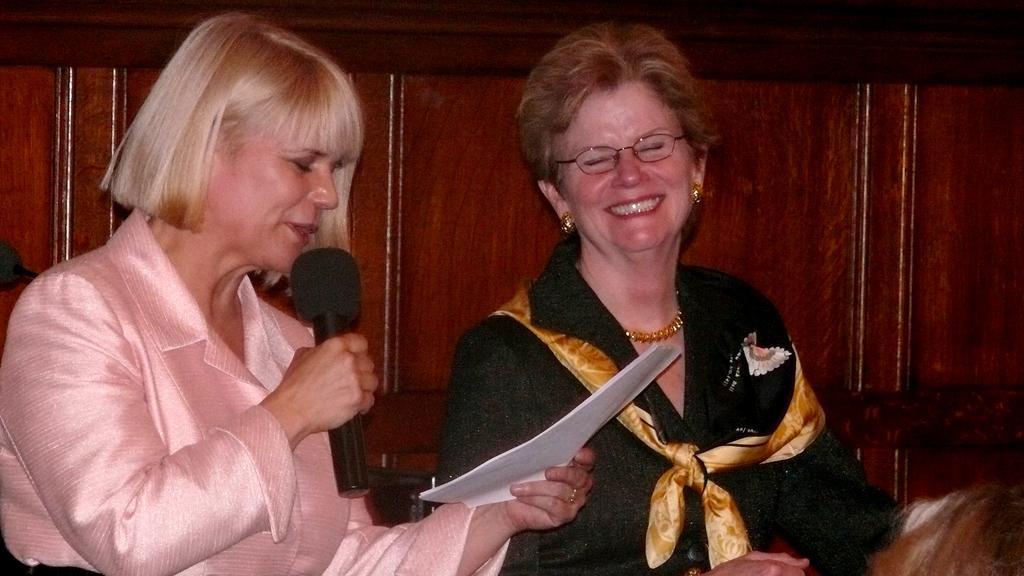How would you summarize this image in a sentence or two? A woman in the left is holding mic and a paper is speaking. A woman on the right wearing specs, earrings, chain and a scarf is smiling. In the background there is a wooden wall. 